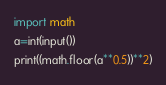<code> <loc_0><loc_0><loc_500><loc_500><_Python_>import math
a=int(input())
print((math.floor(a**0.5))**2)</code> 